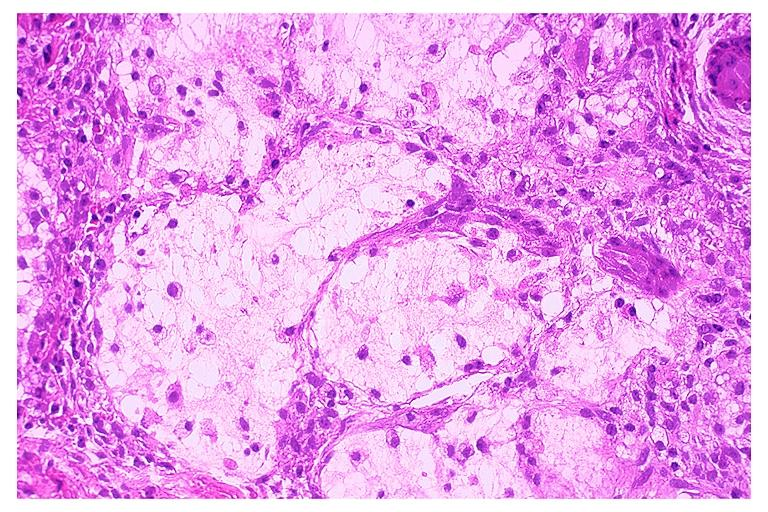s lymphoma present?
Answer the question using a single word or phrase. No 